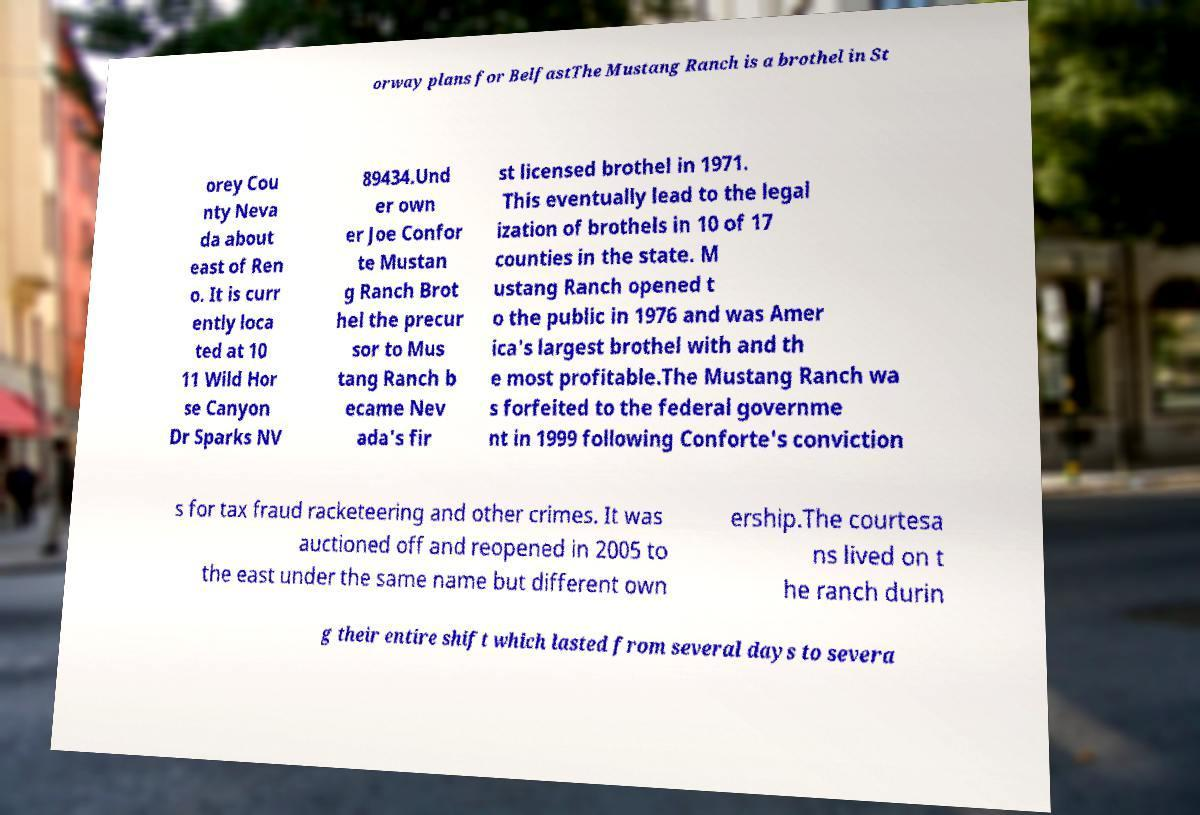Could you extract and type out the text from this image? orway plans for BelfastThe Mustang Ranch is a brothel in St orey Cou nty Neva da about east of Ren o. It is curr ently loca ted at 10 11 Wild Hor se Canyon Dr Sparks NV 89434.Und er own er Joe Confor te Mustan g Ranch Brot hel the precur sor to Mus tang Ranch b ecame Nev ada's fir st licensed brothel in 1971. This eventually lead to the legal ization of brothels in 10 of 17 counties in the state. M ustang Ranch opened t o the public in 1976 and was Amer ica's largest brothel with and th e most profitable.The Mustang Ranch wa s forfeited to the federal governme nt in 1999 following Conforte's conviction s for tax fraud racketeering and other crimes. It was auctioned off and reopened in 2005 to the east under the same name but different own ership.The courtesa ns lived on t he ranch durin g their entire shift which lasted from several days to severa 